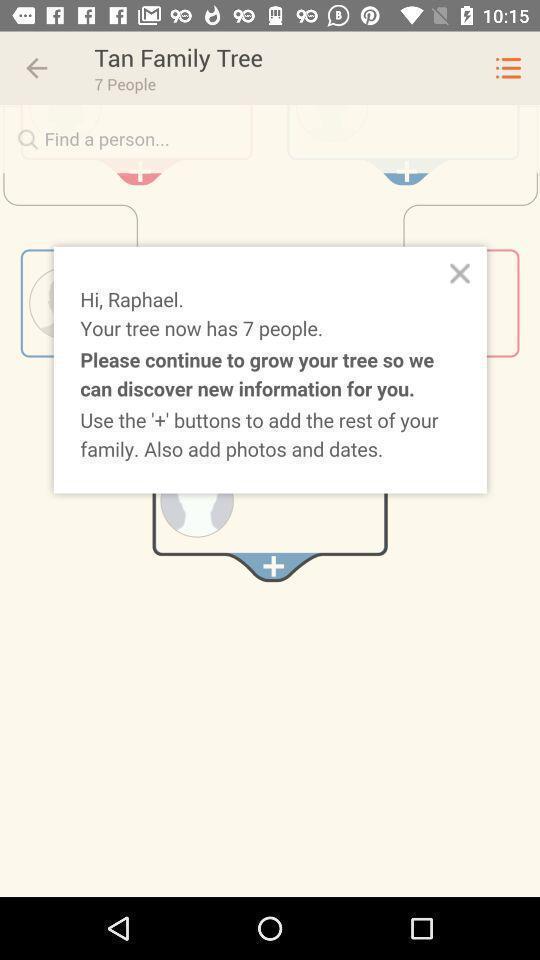Tell me what you see in this picture. Popup showing information about a family tree. 